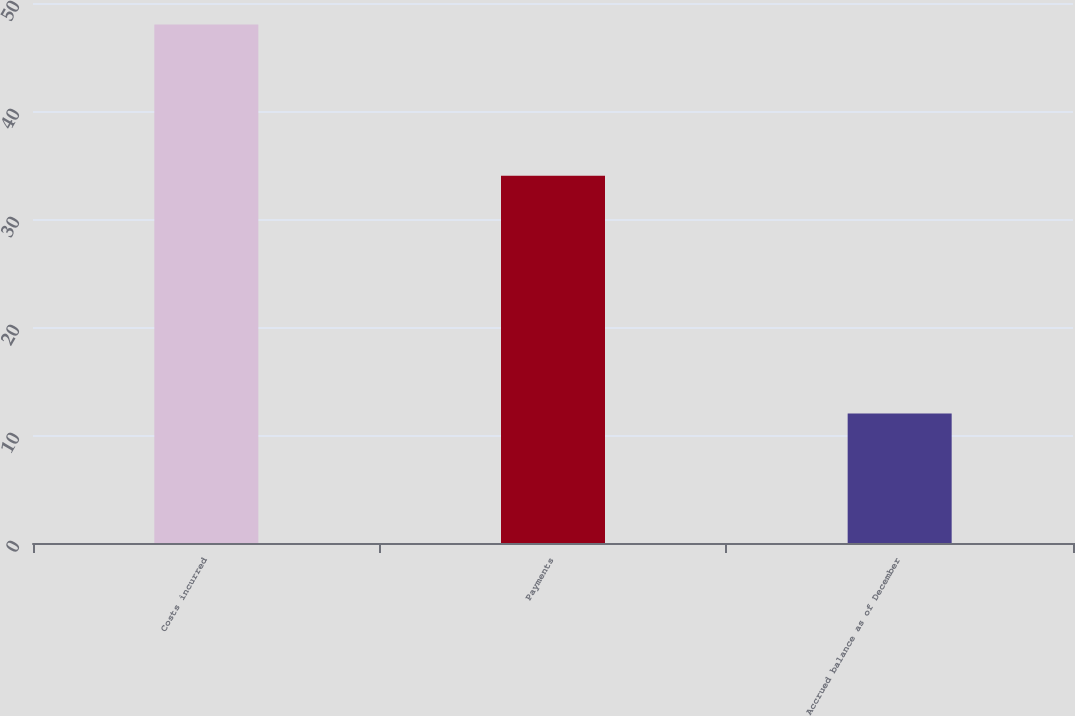Convert chart to OTSL. <chart><loc_0><loc_0><loc_500><loc_500><bar_chart><fcel>Costs incurred<fcel>Payments<fcel>Accrued balance as of December<nl><fcel>48<fcel>34<fcel>12<nl></chart> 